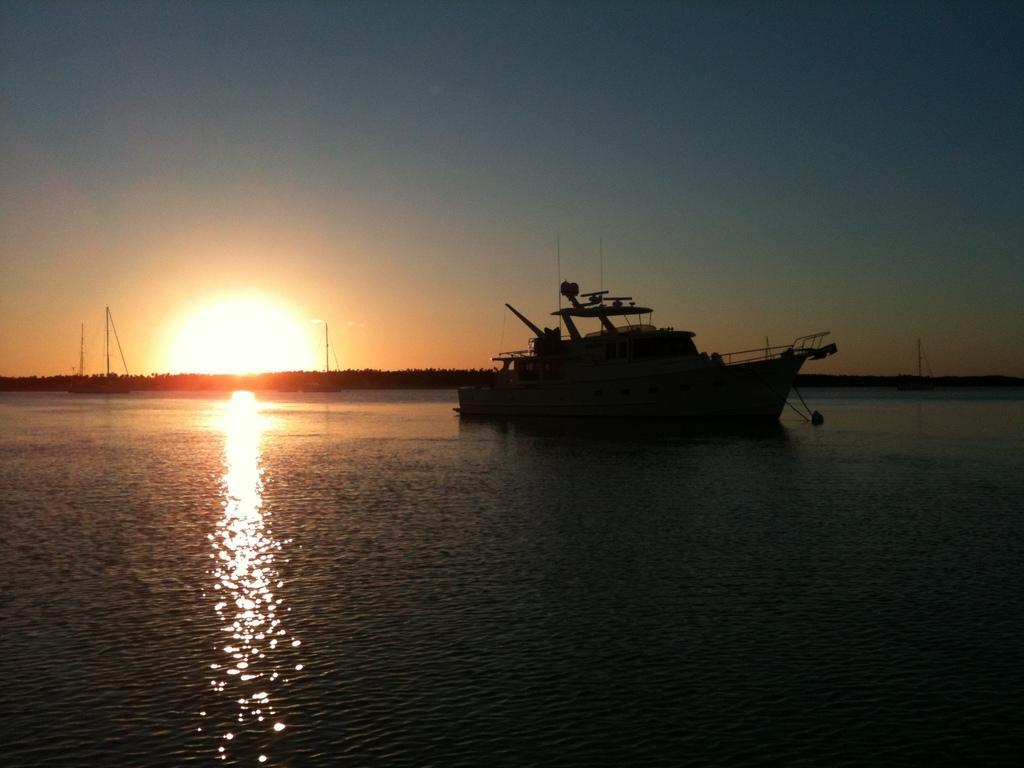Can you describe this image briefly? In this image we can see a ship in the middle of the image and in the background there are few ships on the water and we can see the sunlight and the sky. 